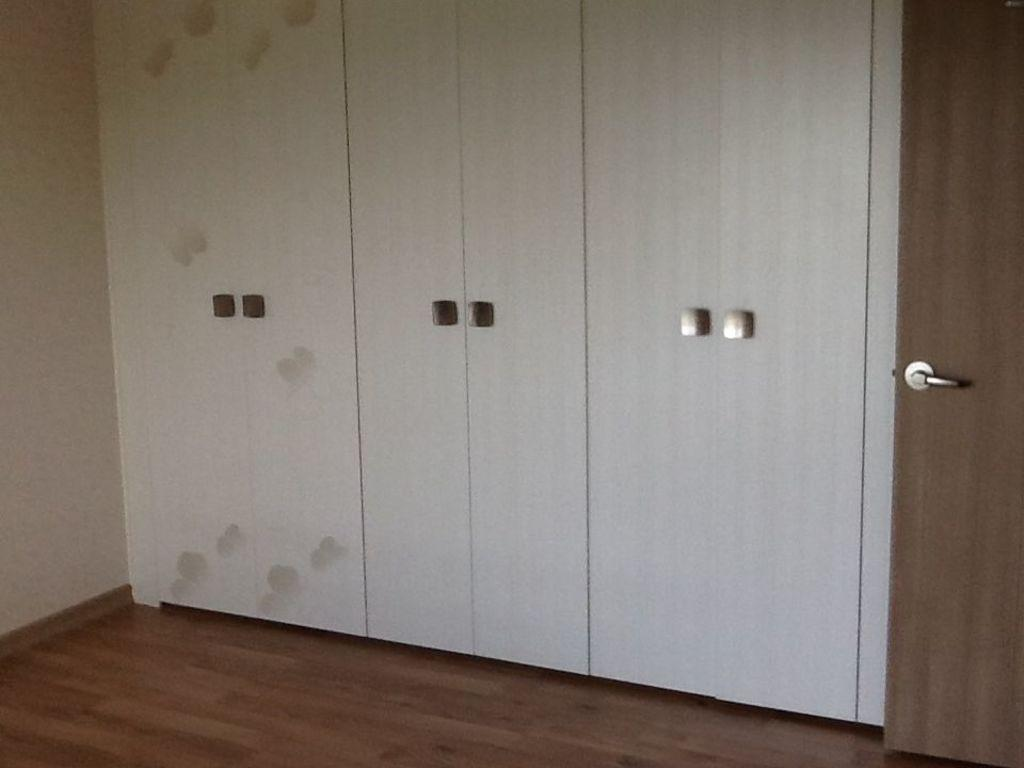What type of furniture is present in the image? There are cupboards in the image. What material is the floor made of? The floor is made of wood. Can you describe the door in the image? There is a door with a handle in the image. What type of toothpaste is on the door handle in the image? There is no toothpaste present on the door handle in the image. What part of the body is the neck located in the image? There is no reference to a neck or any body parts in the image. 